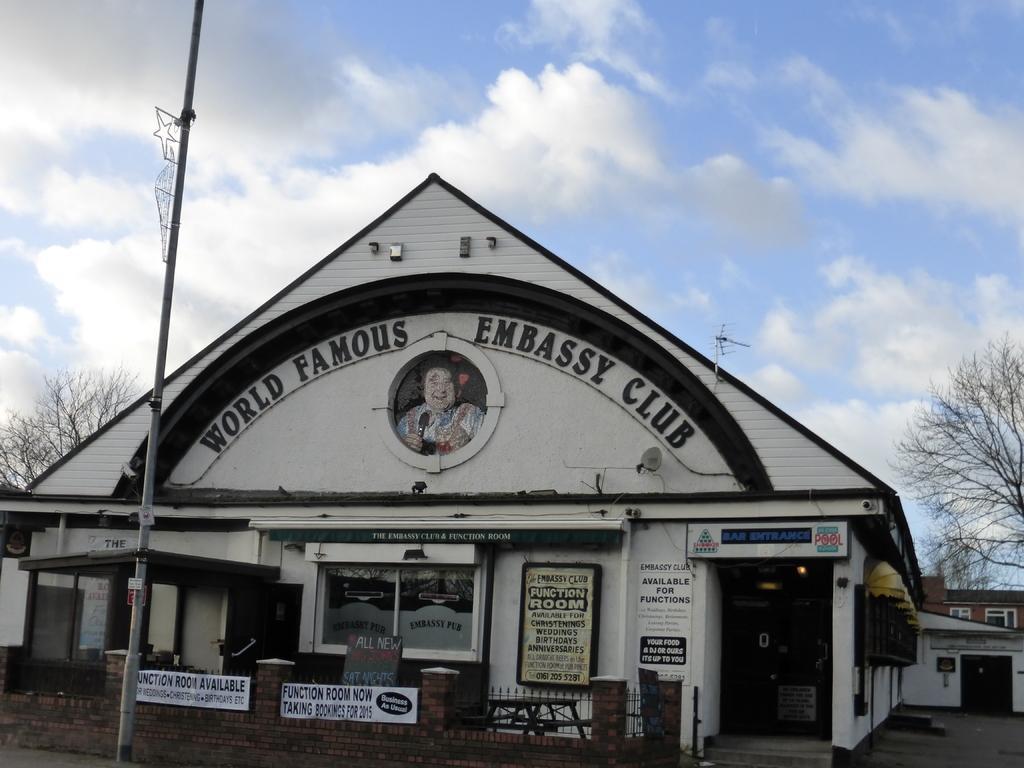How would you summarize this image in a sentence or two? In the foreground of this image, there is a pole and it seems like a shed and few posters and boards to it. On the other side, there are trees. In the background, there is a building, sky and the cloud. 